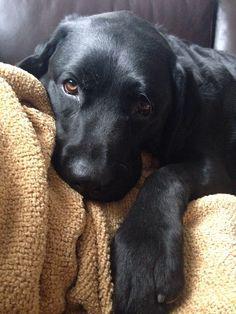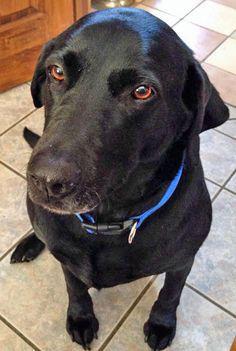The first image is the image on the left, the second image is the image on the right. Examine the images to the left and right. Is the description "One dog is wearing a collar and sitting." accurate? Answer yes or no. Yes. The first image is the image on the left, the second image is the image on the right. Evaluate the accuracy of this statement regarding the images: "Only black labrador retrievers are shown, and one dog is in a reclining pose on something soft, and at least one dog wears a collar.". Is it true? Answer yes or no. Yes. 